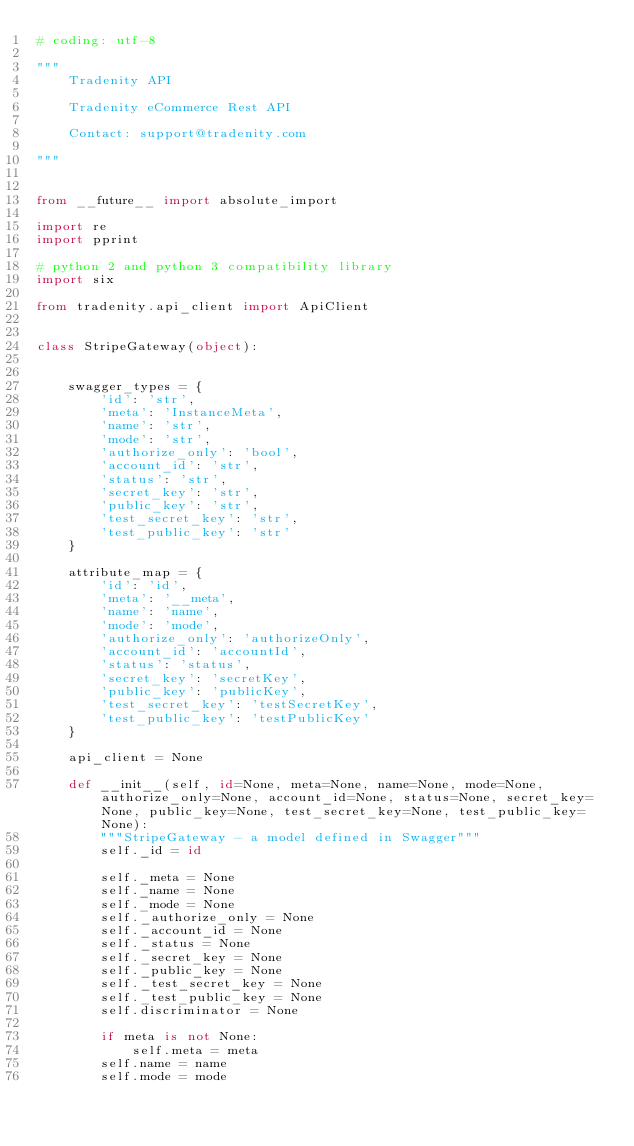<code> <loc_0><loc_0><loc_500><loc_500><_Python_># coding: utf-8

"""
    Tradenity API

    Tradenity eCommerce Rest API

    Contact: support@tradenity.com

"""


from __future__ import absolute_import

import re
import pprint

# python 2 and python 3 compatibility library
import six

from tradenity.api_client import ApiClient


class StripeGateway(object):
    

    swagger_types = { 
        'id': 'str',
        'meta': 'InstanceMeta',
        'name': 'str',
        'mode': 'str',
        'authorize_only': 'bool',
        'account_id': 'str',
        'status': 'str',
        'secret_key': 'str',
        'public_key': 'str',
        'test_secret_key': 'str',
        'test_public_key': 'str'
    }

    attribute_map = { 
        'id': 'id',
        'meta': '__meta',
        'name': 'name',
        'mode': 'mode',
        'authorize_only': 'authorizeOnly',
        'account_id': 'accountId',
        'status': 'status',
        'secret_key': 'secretKey',
        'public_key': 'publicKey',
        'test_secret_key': 'testSecretKey',
        'test_public_key': 'testPublicKey'
    }

    api_client = None

    def __init__(self, id=None, meta=None, name=None, mode=None, authorize_only=None, account_id=None, status=None, secret_key=None, public_key=None, test_secret_key=None, test_public_key=None):
        """StripeGateway - a model defined in Swagger"""
        self._id = id

        self._meta = None
        self._name = None
        self._mode = None
        self._authorize_only = None
        self._account_id = None
        self._status = None
        self._secret_key = None
        self._public_key = None
        self._test_secret_key = None
        self._test_public_key = None
        self.discriminator = None

        if meta is not None:
            self.meta = meta
        self.name = name
        self.mode = mode</code> 